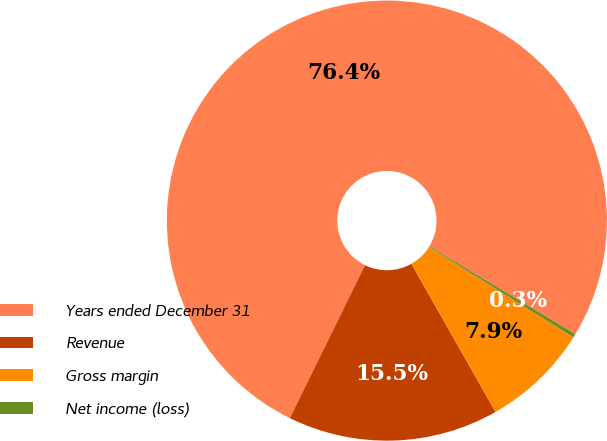<chart> <loc_0><loc_0><loc_500><loc_500><pie_chart><fcel>Years ended December 31<fcel>Revenue<fcel>Gross margin<fcel>Net income (loss)<nl><fcel>76.37%<fcel>15.49%<fcel>7.88%<fcel>0.27%<nl></chart> 